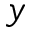<formula> <loc_0><loc_0><loc_500><loc_500>y</formula> 